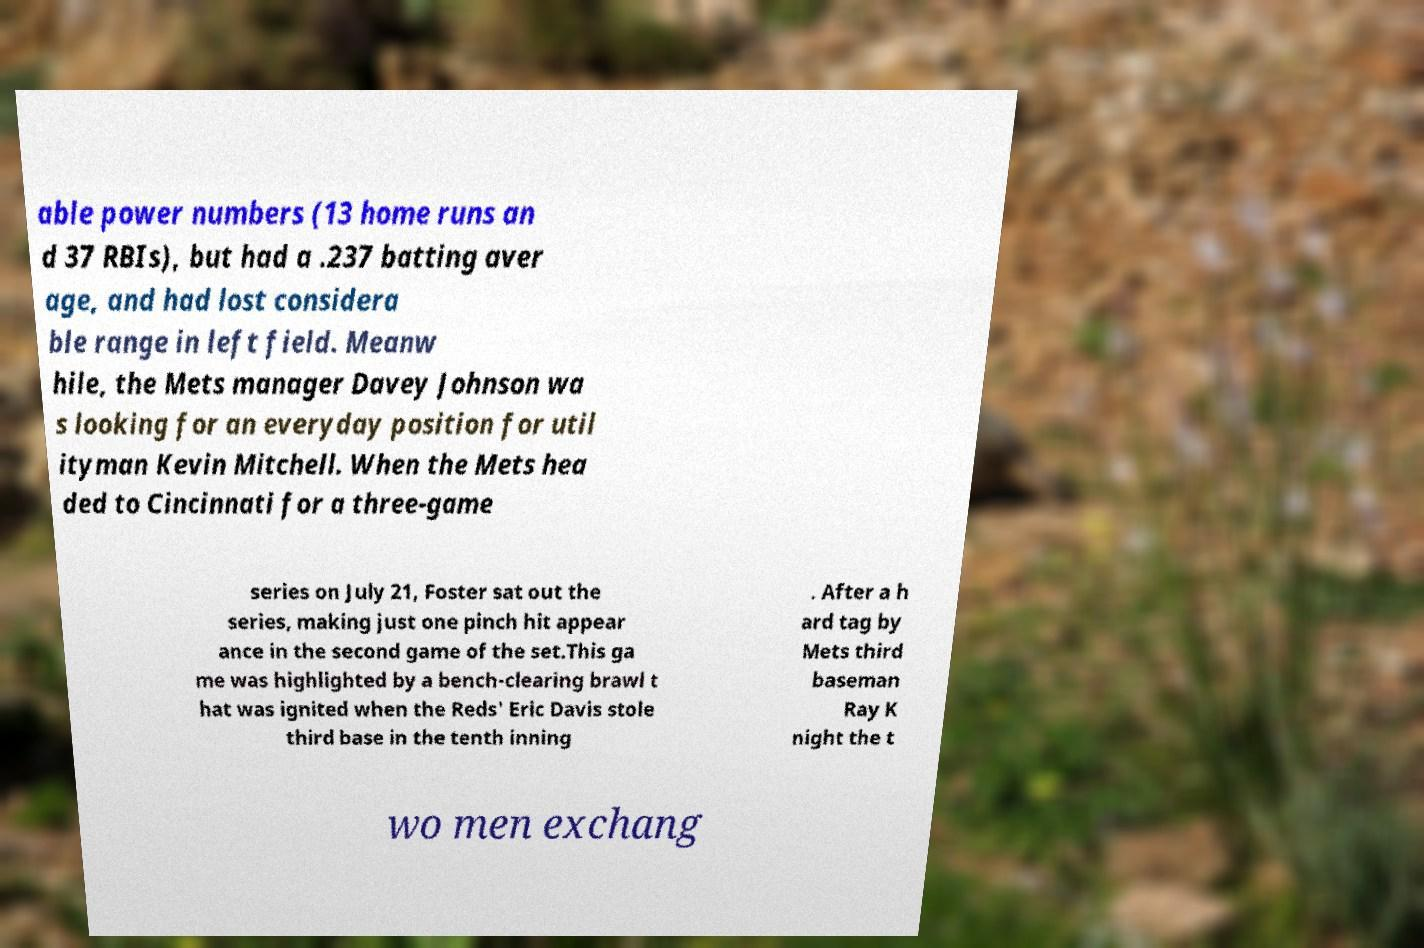For documentation purposes, I need the text within this image transcribed. Could you provide that? able power numbers (13 home runs an d 37 RBIs), but had a .237 batting aver age, and had lost considera ble range in left field. Meanw hile, the Mets manager Davey Johnson wa s looking for an everyday position for util ityman Kevin Mitchell. When the Mets hea ded to Cincinnati for a three-game series on July 21, Foster sat out the series, making just one pinch hit appear ance in the second game of the set.This ga me was highlighted by a bench-clearing brawl t hat was ignited when the Reds' Eric Davis stole third base in the tenth inning . After a h ard tag by Mets third baseman Ray K night the t wo men exchang 